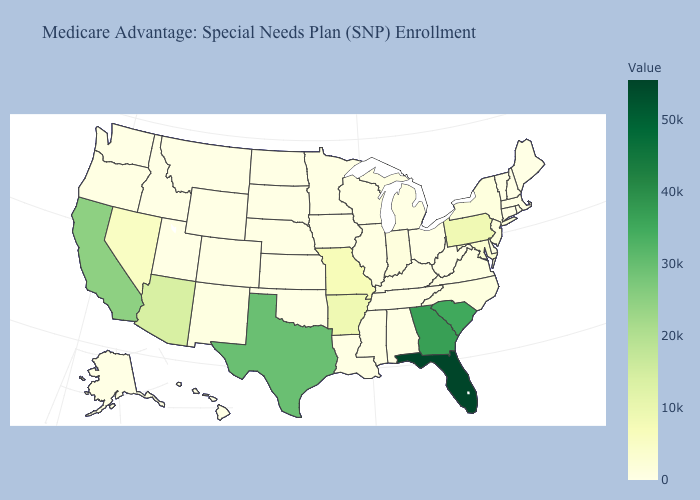Does Rhode Island have the lowest value in the Northeast?
Short answer required. Yes. Does Delaware have the lowest value in the USA?
Keep it brief. No. Does West Virginia have the lowest value in the South?
Give a very brief answer. Yes. Does the map have missing data?
Answer briefly. No. Among the states that border Ohio , does Michigan have the highest value?
Answer briefly. No. Which states have the lowest value in the MidWest?
Give a very brief answer. North Dakota, South Dakota. Among the states that border Alabama , does Tennessee have the lowest value?
Quick response, please. Yes. Does Kentucky have the lowest value in the USA?
Short answer required. No. Does Florida have the highest value in the USA?
Quick response, please. Yes. Which states hav the highest value in the MidWest?
Write a very short answer. Missouri. 